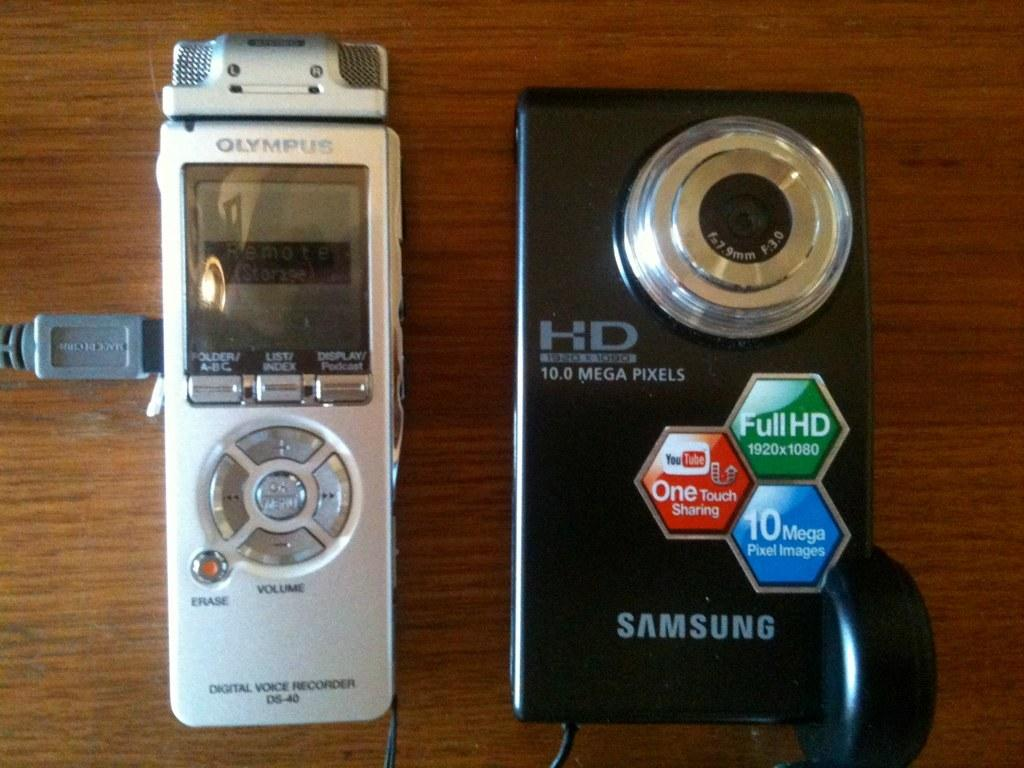<image>
Render a clear and concise summary of the photo. A Samsung camera and audio recording device next to each other. 